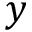<formula> <loc_0><loc_0><loc_500><loc_500>y</formula> 